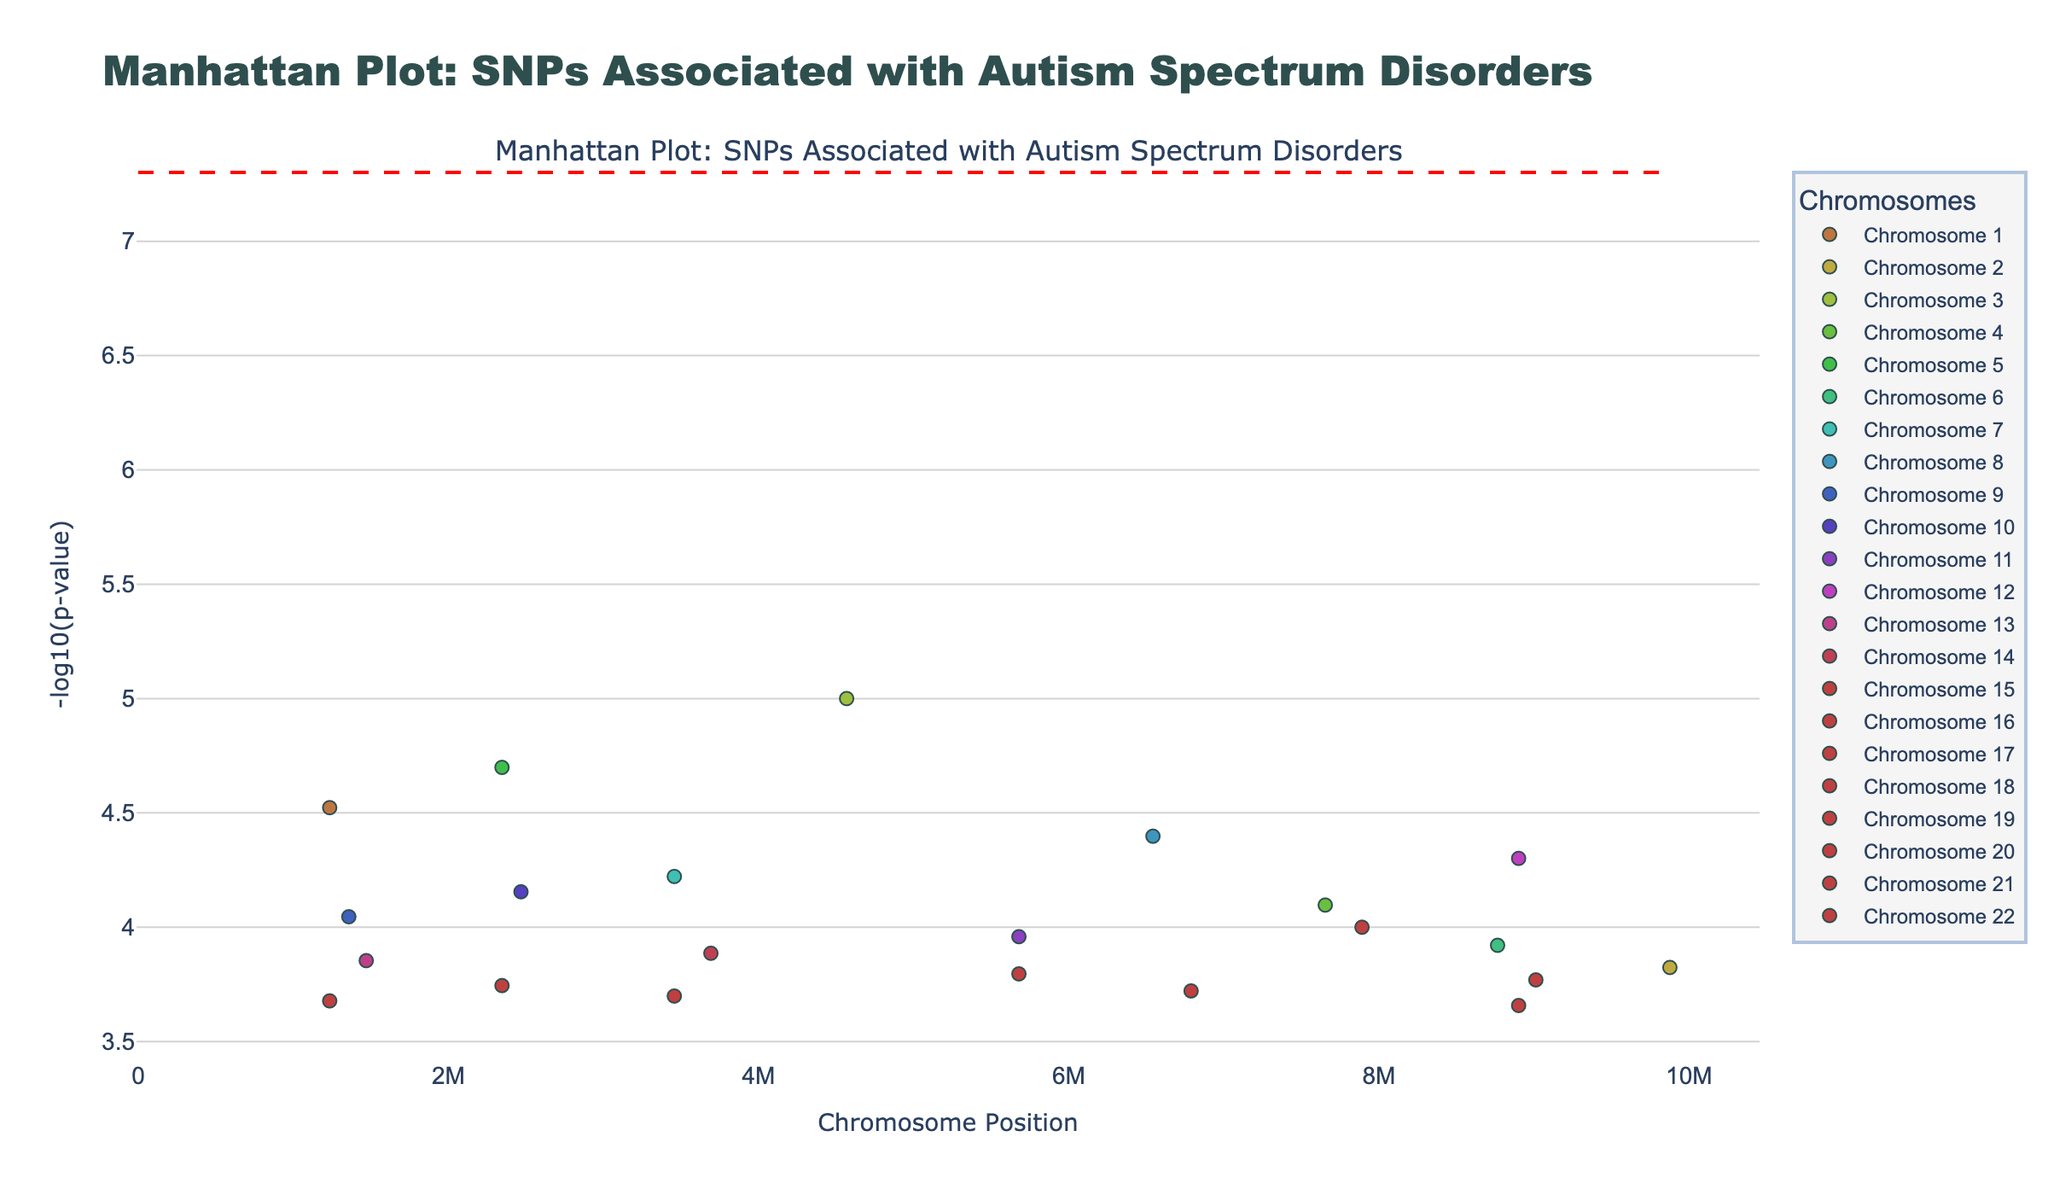What is the title of the plot? The title is located at the top center of the plot. Read it to identify the text.
Answer: Manhattan Plot: SNPs Associated with Autism Spectrum Disorders What does the y-axis represent? Read the label on the y-axis to understand what it represents.
Answer: -log10(p-value) Which SNP has the smallest p-value? The SNP with the smallest p-value will have the highest -log10(p-value). Identify the highest point on the plot and read the corresponding SNP.
Answer: rs4567890 How many chromosomes are represented in the plot? Look at the legend or the unique colors representing different chromosomes to count the number of chromosomes.
Answer: 22 What is the approximate position of the most significant SNP on chromosome 1? Look for the highest point within the data points colored according to chromosome 1 and read the x-axis for its position.
Answer: 1234567 Are there any chromosomes without SNPs with p-values less than 0.00015? Review the y-values for data points colored for each chromosome to check if any chromosomes lack any points above the threshold of -log10(0.00015).
Answer: No What does the horizontal red dashed line represent? Examine the color and style of the horizontal line and read the figure legend or common knowledge about Manhattan plots to infer its meaning.
Answer: Significance Threshold Which chromosome has the SNP with the highest -log10(p-value) position? Identify the highest data point on the y-axis and then determine which chromosome color it is associated with based on the legend.
Answer: Chromosome 3 How many SNPs on chromosome 7 have p-values lower than 0.0001? Check the data points for chromosome 7 and count how many of them are above -log10(0.0001).
Answer: 0 What is the position of the SNP with the highest p-value? Identify the lowest point on the y-axis and read its position from the x-axis.
Answer: 8901234 